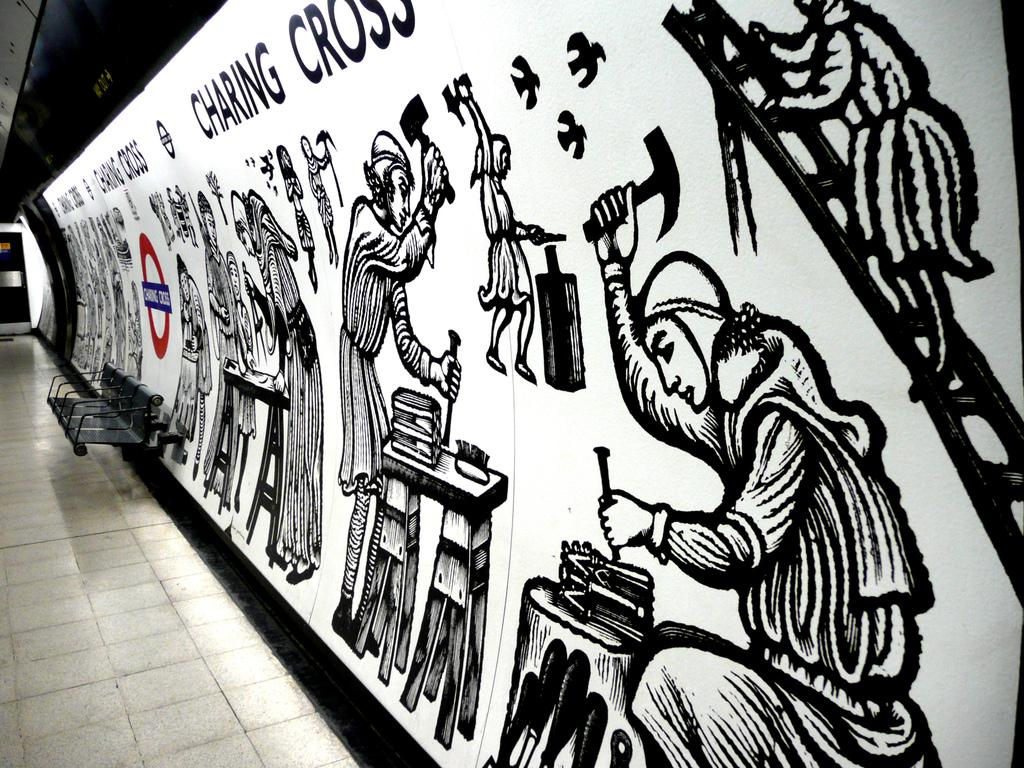What type of surface is visible in the image? There is a floor in the image. What type of furniture is present in the image? There is a bench in the image. What can be seen on the wall on the right side of the image? There is a painting on the wall on the right side of the image. How many babies are crawling on the floor in the image? There are no babies present in the image; it only features a floor, a bench, and a painting on the wall. 